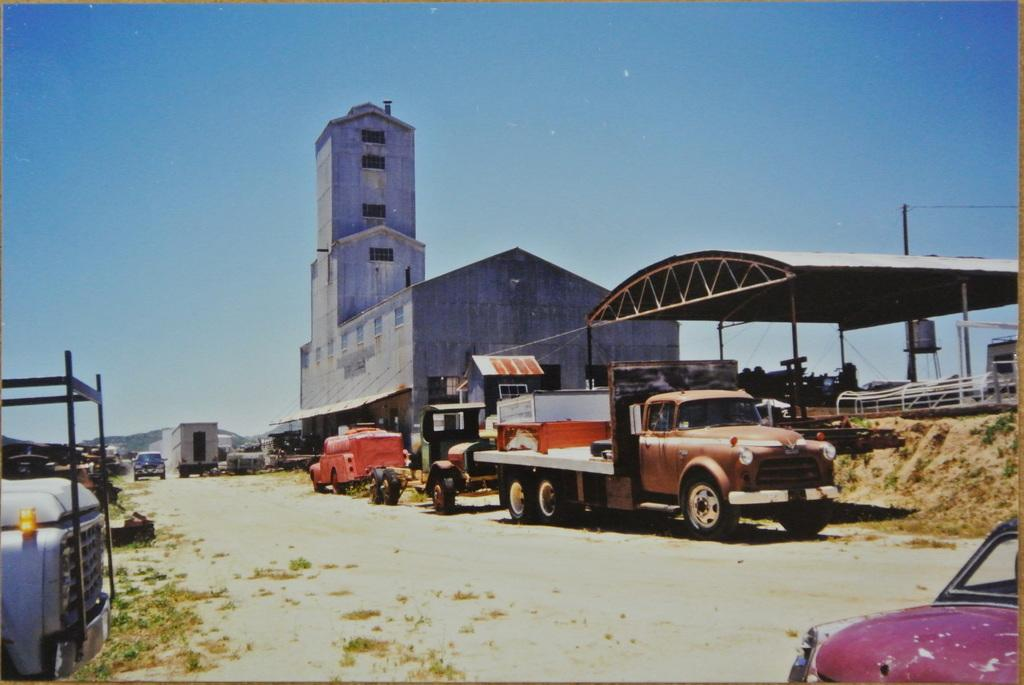What is the main subject of the image? The main subject of the image is a group of vehicles. What structures are visible behind the vehicles? There is a shed and a building behind the vehicles. What else can be seen in the image besides the vehicles and structures? There is a pole with wires in the image. What is visible at the top of the image? The sky is visible at the top of the image. Where is the pickle located on the stage in the image? There is no pickle or stage present in the image. What type of hill can be seen in the background of the image? There is no hill visible in the image; it features a group of vehicles, structures, and a pole with wires. 